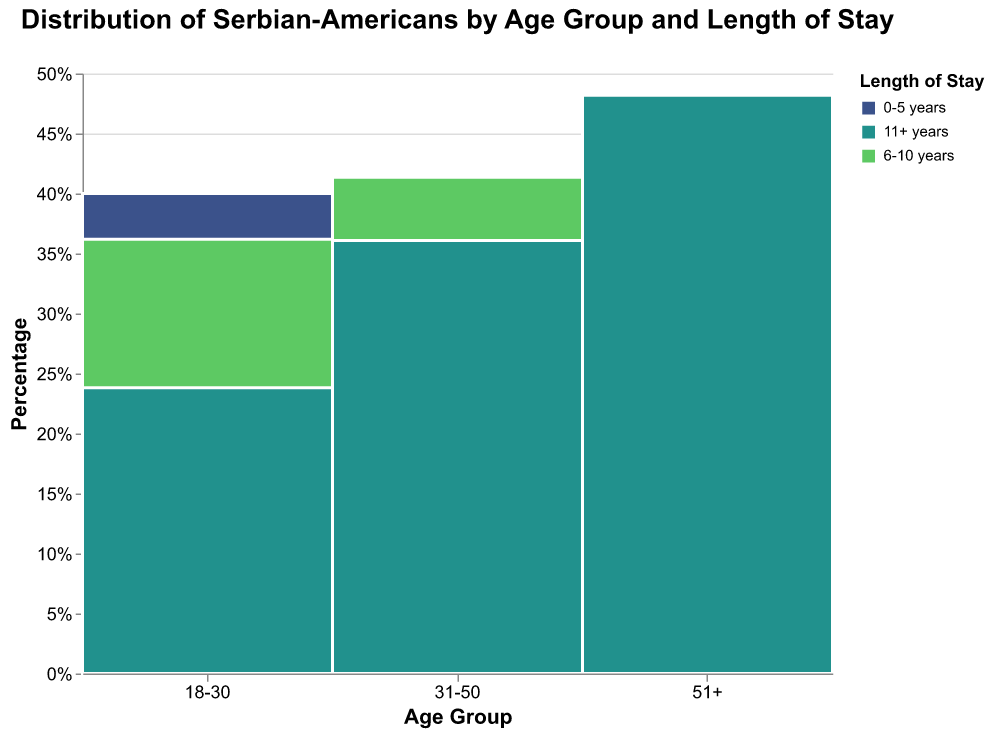What is the title of the figure? The title is usually found at the top of the figure. In this case, it provides context for what the data is about.
Answer: Distribution of Serbian-Americans by Age Group and Length of Stay What age group has the highest percentage for the '11+ years' length of stay? To answer, look at the segments filled with the color representing '11+ years' and compare their heights across different age groups.
Answer: Age group 51+ What percentage of Serbian-Americans aged 18-30 have a 0-5 years length of stay? Look at the 18-30 age group on the x-axis and find the segment representing 0-5 years. The information can be deduced from the tooltip or by calculating the segment height as a proportion of the total height for that age group.
Answer: 42/105 or 40% Which length of stay category has the largest proportion in the 31-50 age group? Look for the relative height of each segment within the 31-50 age group's column. The segment representing the category that occupies the largest proportion of the total height for this age group is the answer.
Answer: 6-10 years How does the English proficiency level vary among different age groups for those with a length of stay of 6-10 years? Examine the segments for each age group within the '6-10 years' length of stay category and observe the tooltip for each segment to see the English proficiency levels.
Answer: Varies between Intermediate (18-30, 51+) and Advanced (31-50) Compare the percentage of Serbian proficiency 'Fluent' in the 0-5 years length of stay for the 18-30 and 31-50 age groups. Identify the segments for '0-5 years' within both age groups and assess their relative heights, which indicate the percentages.
Answer: Roughly equal, as both are Fluent What is the percentage difference between the 'Intermediate' Serbian proficiency in the 51+ age group with 6-10 years and 11+ years lengths of stay? Compare the heights of the 'Intermediate' segments for 6-10 years and 11+ years within the 51+ age group and calculate the difference in their respective percentages.
Answer: Intermediate is 0% for 51+ in both categories Which age group has the least proficiency in English for those who have stayed 0-5 years? By comparing the heights of the segments corresponding to '0-5 years' within each age group, determine the one with the shorter segment for English proficiency.
Answer: 51+ How does the Serbian proficiency level change with length of stay for the age group 31-50? Inspect the 31-50 age group along the x-axis and observe the segments for each length of stay, noting changes in color which represent different proficiency levels.
Answer: Declines from Fluent to Intermediate as length of stay increases 